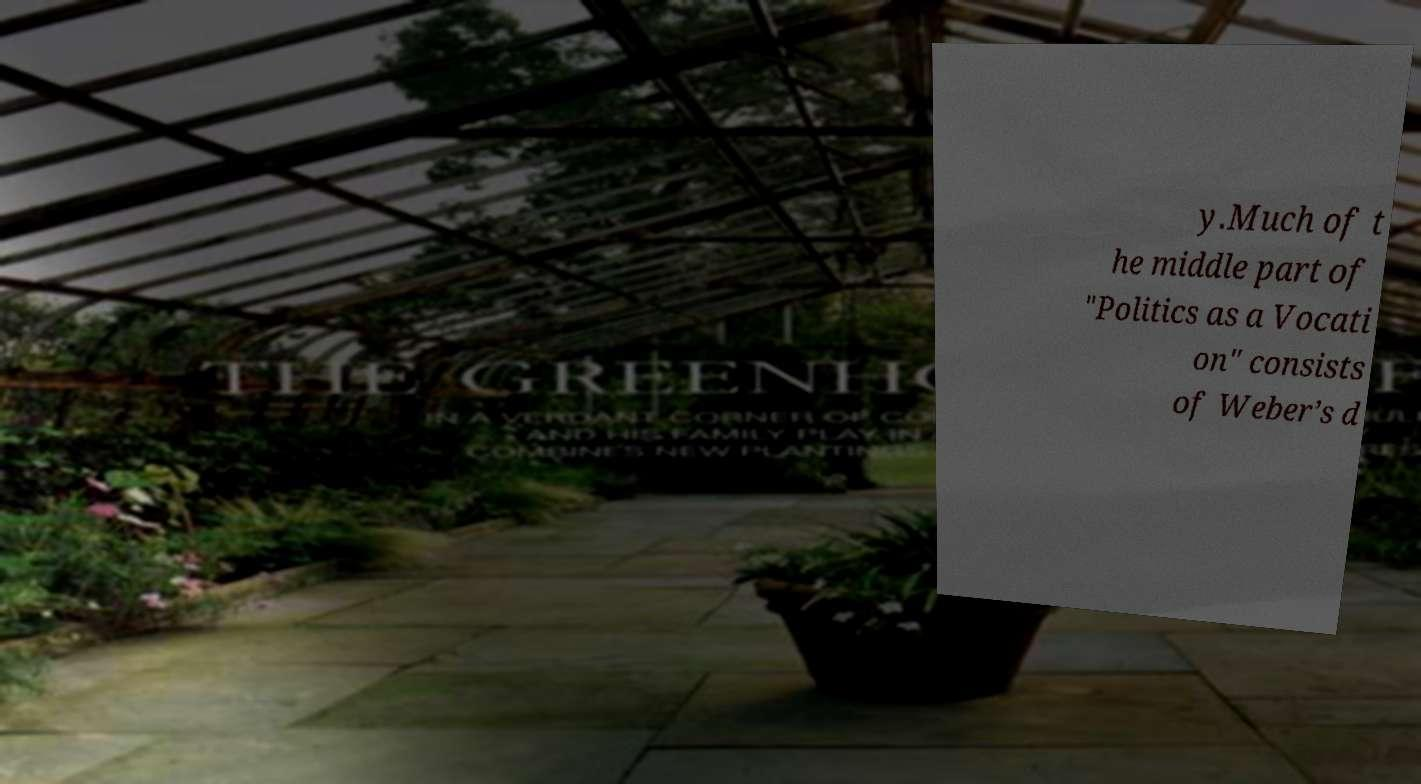What messages or text are displayed in this image? I need them in a readable, typed format. y.Much of t he middle part of "Politics as a Vocati on" consists of Weber’s d 